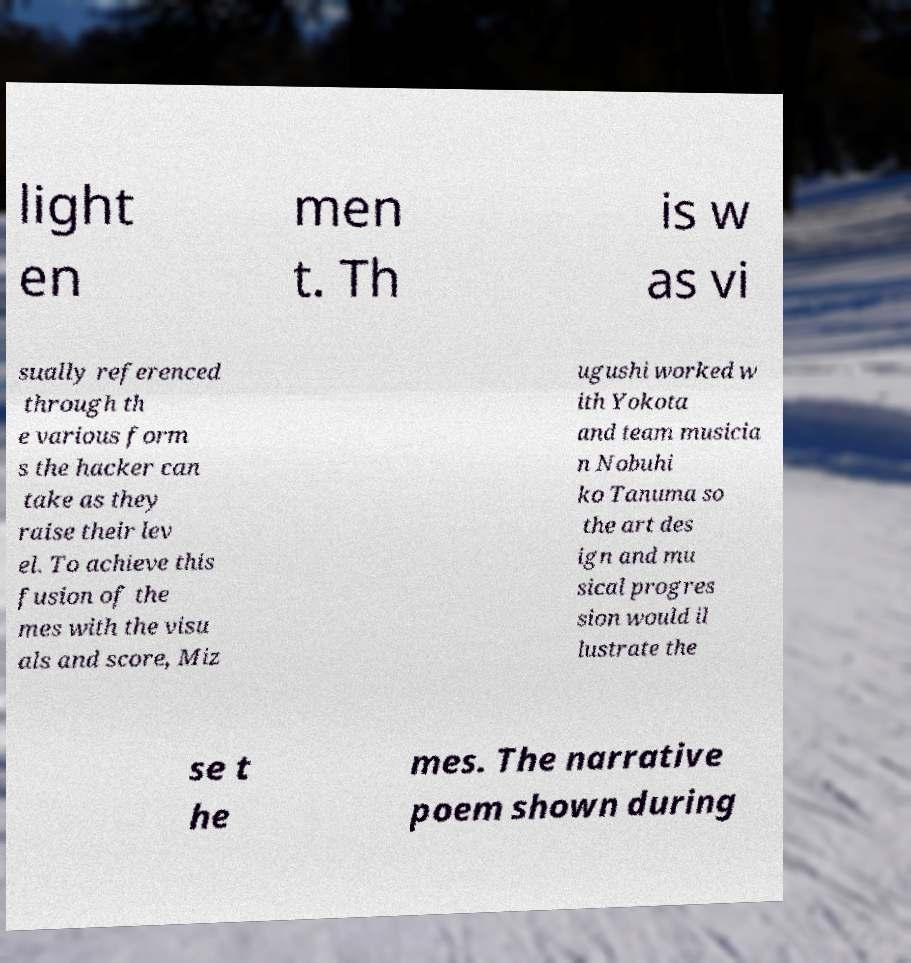For documentation purposes, I need the text within this image transcribed. Could you provide that? light en men t. Th is w as vi sually referenced through th e various form s the hacker can take as they raise their lev el. To achieve this fusion of the mes with the visu als and score, Miz ugushi worked w ith Yokota and team musicia n Nobuhi ko Tanuma so the art des ign and mu sical progres sion would il lustrate the se t he mes. The narrative poem shown during 